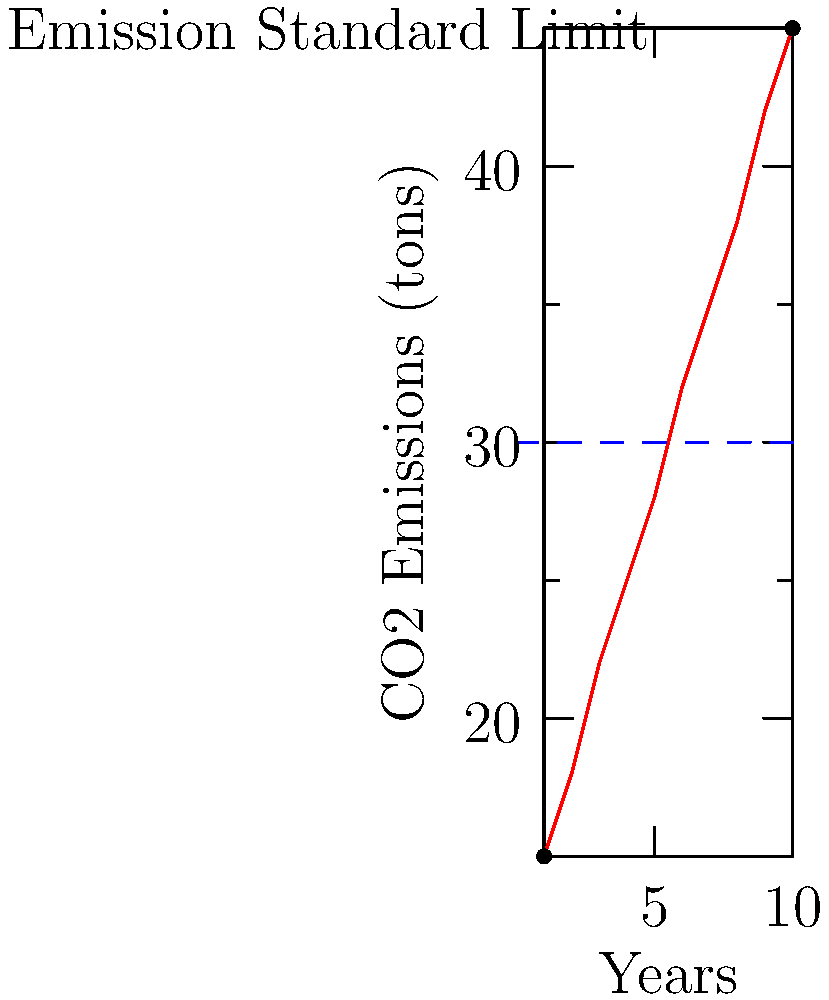Based on the scatter plot showing CO2 emissions from an industrial facility over 10 years, in which year did the facility first exceed the emission standard limit? How would you recommend addressing this non-compliance issue? To answer this question, we need to analyze the scatter plot step-by-step:

1. Identify the emission standard limit: The blue dashed line represents the emission standard limit at 30 tons of CO2.

2. Examine the data points:
   Year 1: ~15 tons (below limit)
   Year 2: ~18 tons (below limit)
   Year 3: ~22 tons (below limit)
   Year 4: ~25 tons (below limit)
   Year 5: ~28 tons (below limit)
   Year 6: ~32 tons (exceeds limit)
   Years 7-10: Continue to exceed limit

3. Identify the first year of non-compliance: Year 6

4. Addressing the non-compliance issue:
   a) Issue a formal notice to the facility about the violation.
   b) Require the facility to submit a corrective action plan within a specified timeframe.
   c) Mandate the implementation of more efficient technologies or processes to reduce emissions.
   d) Conduct more frequent inspections to ensure compliance.
   e) If non-compliance persists, consider imposing fines or other penalties as per regulations.
   f) Provide guidance on best practices for emission reduction in the industry.
Answer: Year 6; Issue notice, require corrective action plan, mandate emission reduction measures, increase inspections, consider penalties if non-compliance persists. 